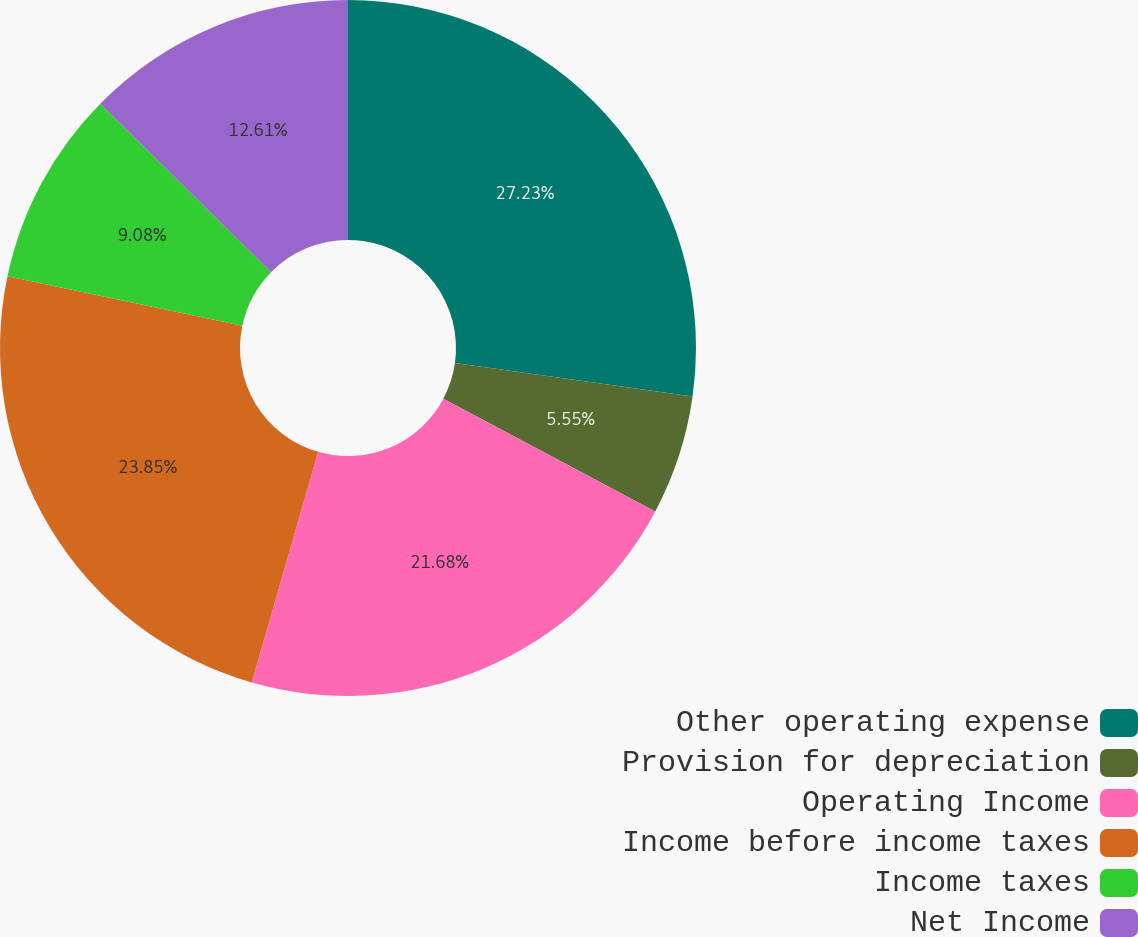<chart> <loc_0><loc_0><loc_500><loc_500><pie_chart><fcel>Other operating expense<fcel>Provision for depreciation<fcel>Operating Income<fcel>Income before income taxes<fcel>Income taxes<fcel>Net Income<nl><fcel>27.23%<fcel>5.55%<fcel>21.68%<fcel>23.85%<fcel>9.08%<fcel>12.61%<nl></chart> 